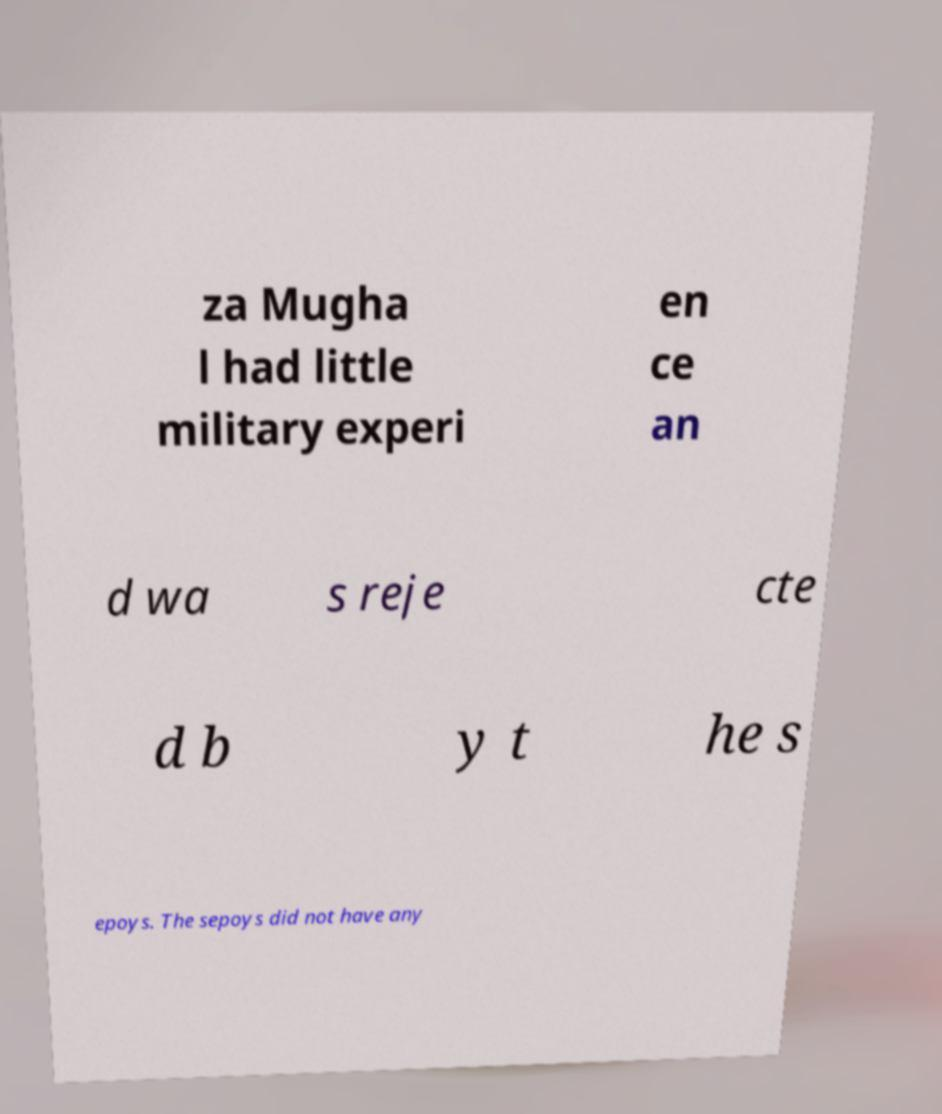There's text embedded in this image that I need extracted. Can you transcribe it verbatim? za Mugha l had little military experi en ce an d wa s reje cte d b y t he s epoys. The sepoys did not have any 